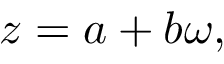<formula> <loc_0><loc_0><loc_500><loc_500>z = a + b \omega ,</formula> 